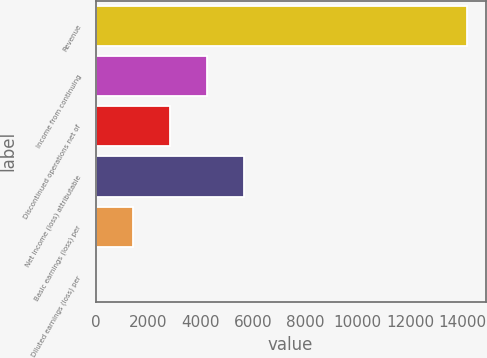Convert chart to OTSL. <chart><loc_0><loc_0><loc_500><loc_500><bar_chart><fcel>Revenue<fcel>Income from continuing<fcel>Discontinued operations net of<fcel>Net income (loss) attributable<fcel>Basic earnings (loss) per<fcel>Diluted earnings (loss) per<nl><fcel>14171<fcel>4252.58<fcel>2835.66<fcel>5669.5<fcel>1418.74<fcel>1.82<nl></chart> 